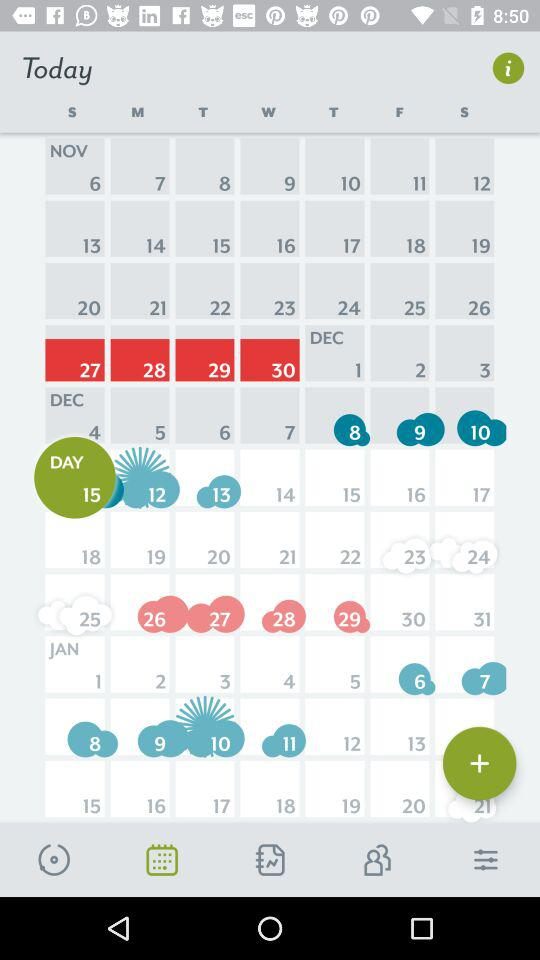Which tab is selected? The selected tab is "Calendar". 